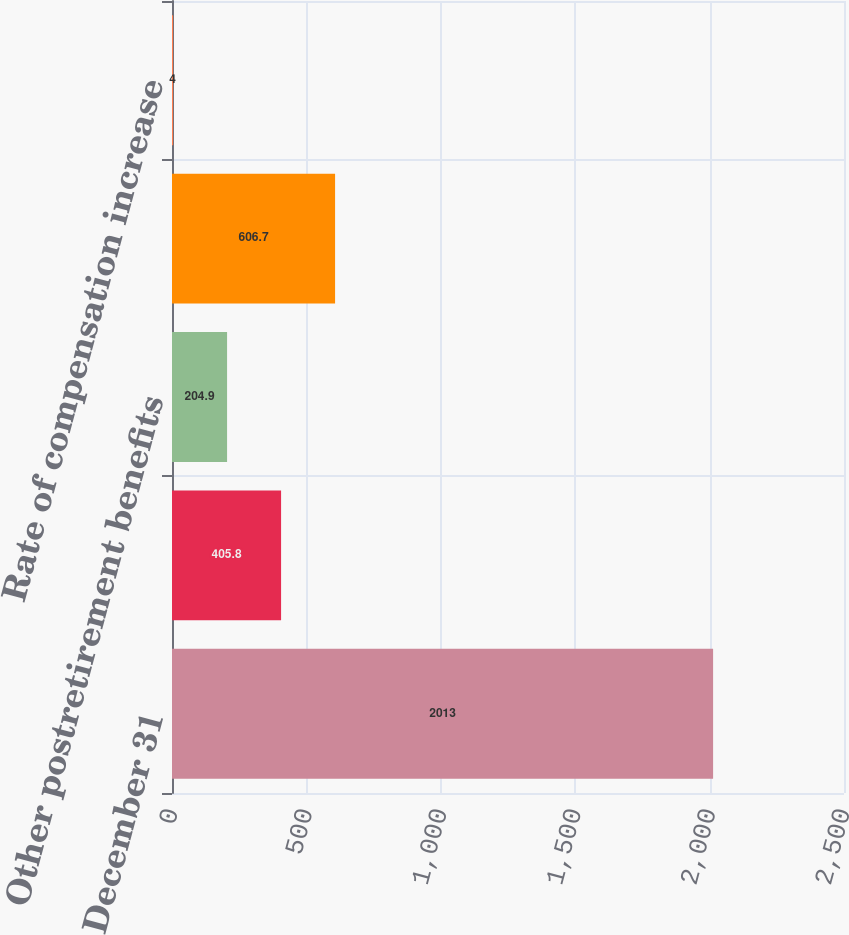<chart> <loc_0><loc_0><loc_500><loc_500><bar_chart><fcel>December 31<fcel>Pension<fcel>Other postretirement benefits<fcel>Expected return on plan assets<fcel>Rate of compensation increase<nl><fcel>2013<fcel>405.8<fcel>204.9<fcel>606.7<fcel>4<nl></chart> 